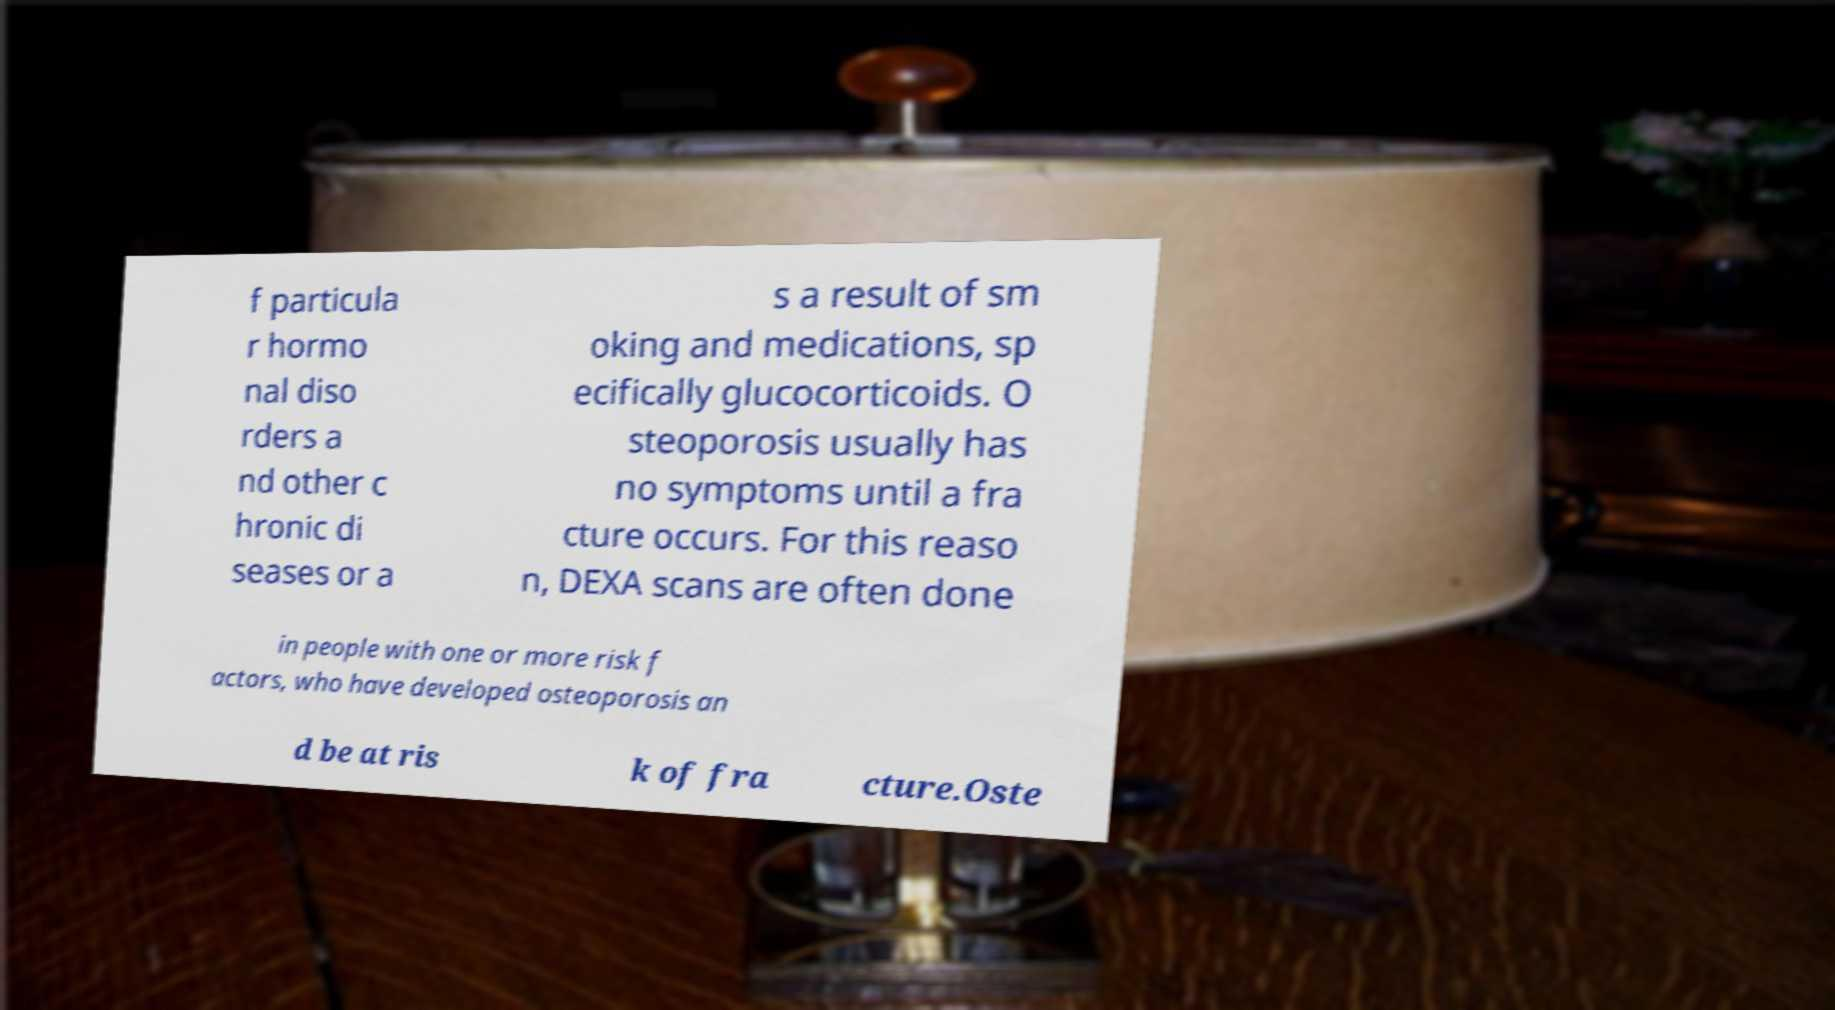Can you accurately transcribe the text from the provided image for me? f particula r hormo nal diso rders a nd other c hronic di seases or a s a result of sm oking and medications, sp ecifically glucocorticoids. O steoporosis usually has no symptoms until a fra cture occurs. For this reaso n, DEXA scans are often done in people with one or more risk f actors, who have developed osteoporosis an d be at ris k of fra cture.Oste 